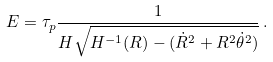Convert formula to latex. <formula><loc_0><loc_0><loc_500><loc_500>E = \tau _ { p } \frac { 1 } { H \sqrt { H ^ { - 1 } ( R ) - ( \dot { R } ^ { 2 } + R ^ { 2 } \dot { \theta } ^ { 2 } ) } } \, .</formula> 